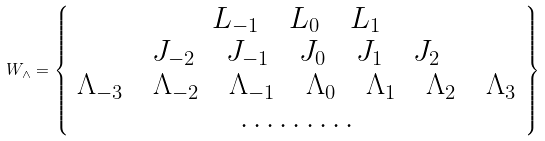Convert formula to latex. <formula><loc_0><loc_0><loc_500><loc_500>W _ { \wedge } = \left \{ \begin{array} { c } L _ { - 1 } \quad L _ { 0 } \quad L _ { 1 } \\ J _ { - 2 } \quad J _ { - 1 } \quad J _ { 0 } \quad J _ { 1 } \quad J _ { 2 } \\ \Lambda _ { - 3 } \quad \Lambda _ { - 2 } \quad \Lambda _ { - 1 } \quad \Lambda _ { 0 } \quad \Lambda _ { 1 } \quad \Lambda _ { 2 } \quad \Lambda _ { 3 } \\ \dots \dots \dots \\ \end{array} \right \}</formula> 